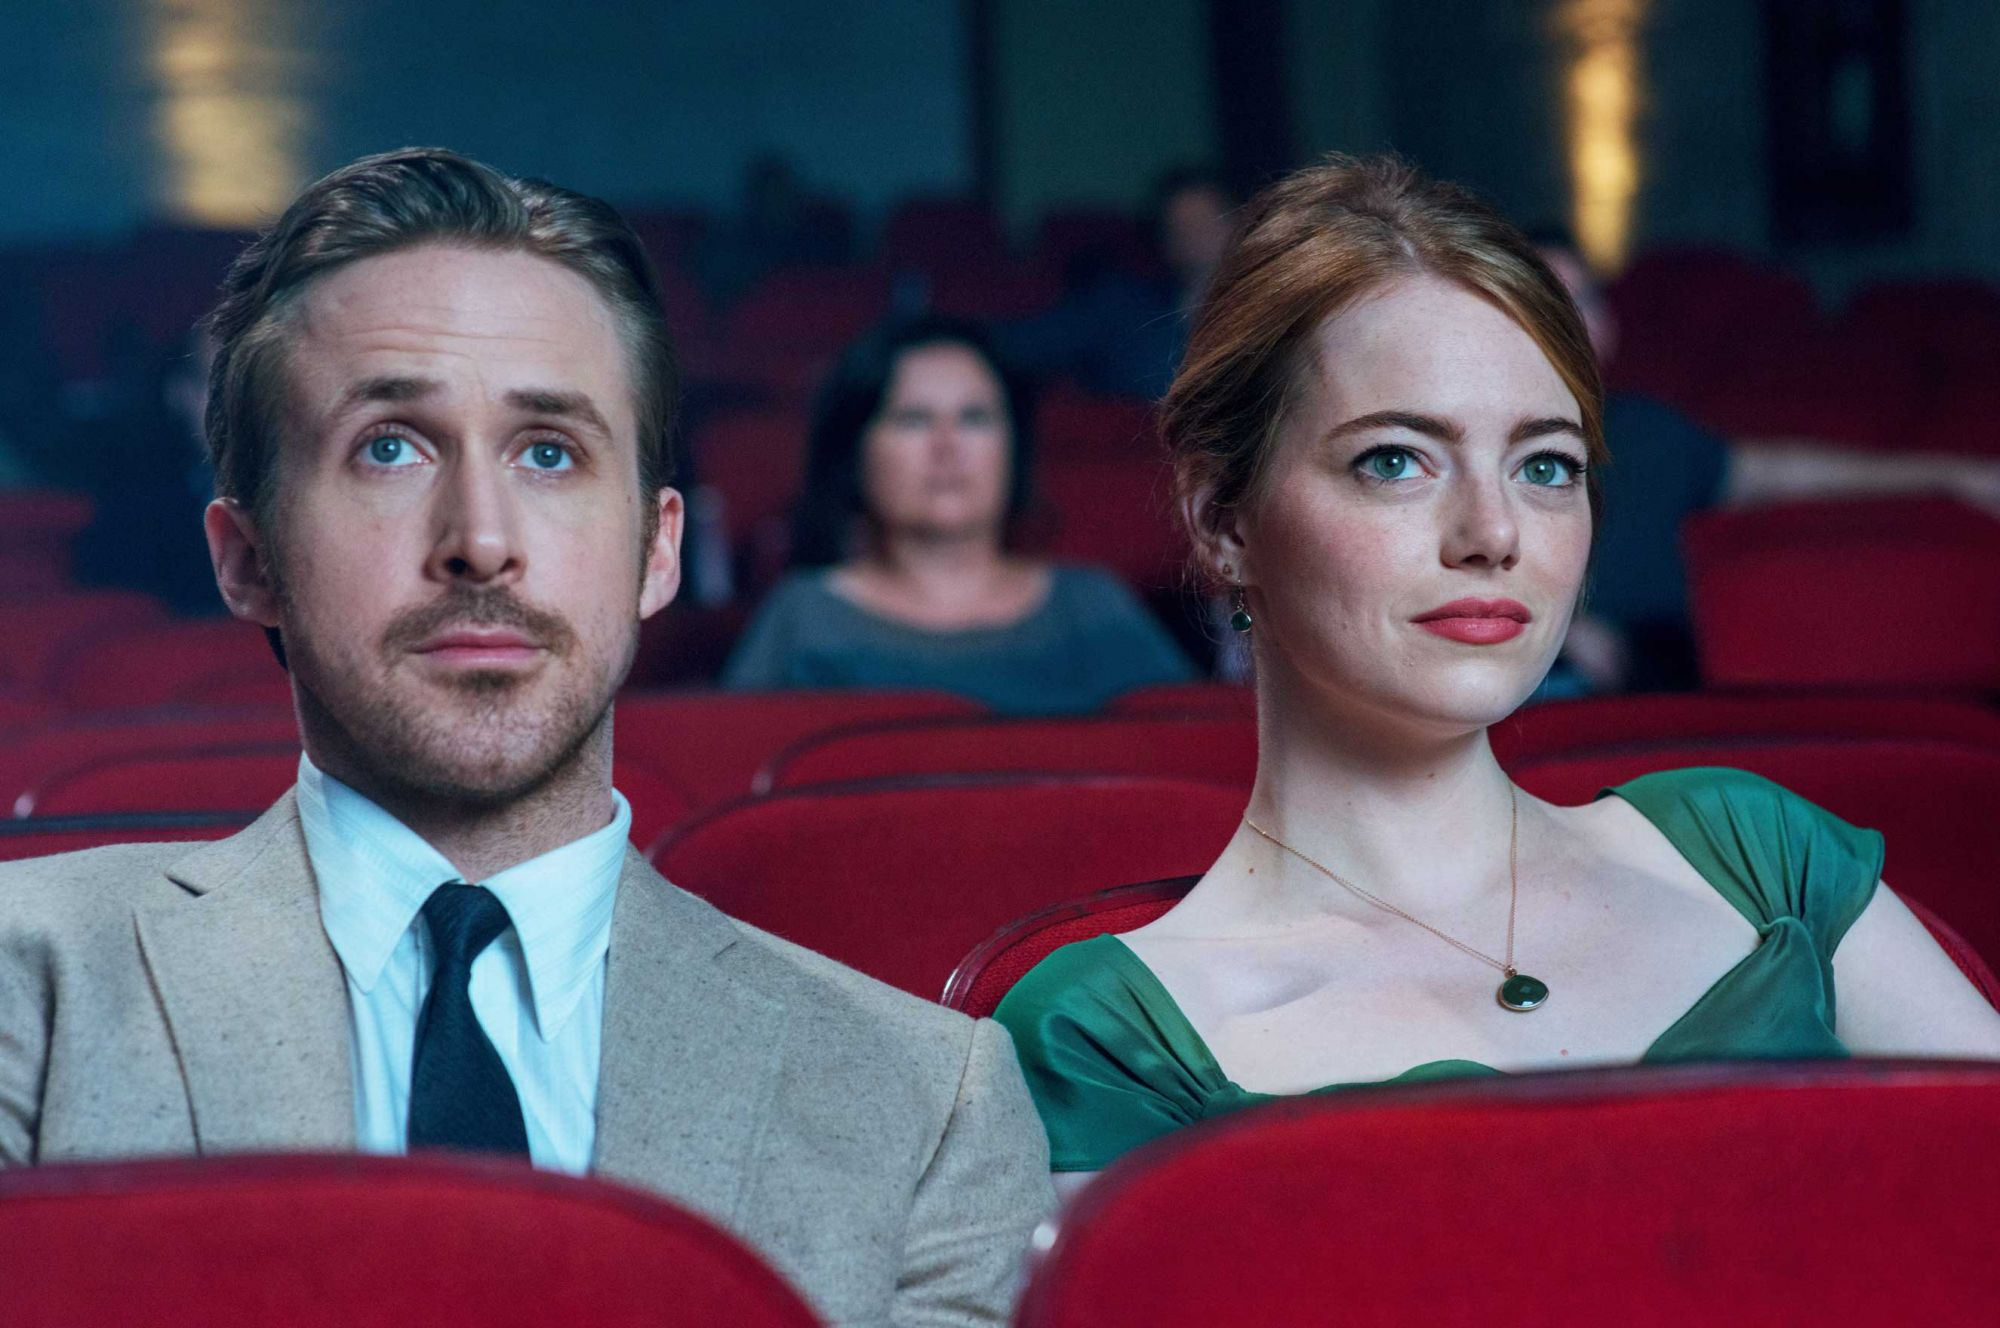Could you create a short story based on this image? In the quiet corners of an old, almost-forgotten theater, Sebastian and Mia sit side by side, their faces softly illuminated by the flickering screen ahead. The air is thick with the scent of popcorn and nostalgia as they find themselves drawn into a black-and-white film reel, a classic from the golden age of cinema. As the plot unfolds, Mia is reminded of her dreams of becoming an actress, her thoughts visiting past auditions, rejections, and the few triumphs that kept her going. Meanwhile, Sebastian’s mind dances with melodies from his jazz compositions, the scenes resonating with a soundtrack that only he could hear. In this space, their passions collide, creating a silent dialogue of hope, dreams, and resilience, captured in a simple movie-going experience. 